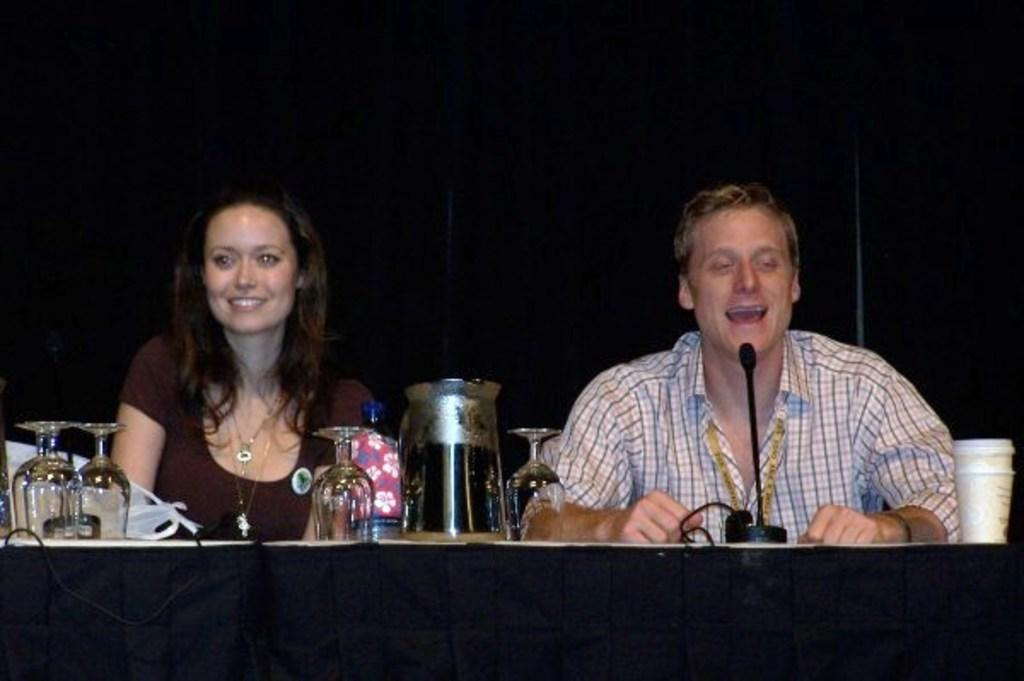How many people are present in the image? There are two people in the image, a man and a woman. What are the man and woman doing in the image? Both the man and woman are sitting behind a table. What objects can be seen on the table in the image? There are wine glasses, a jar, and a microphone on the table. What is the background of the image? There is a black wall in the background. What type of leather is being used to increase the speed of the planes in the image? There are no planes or leather mentioned in the image; it features a man and a woman sitting behind a table with various objects on it. 